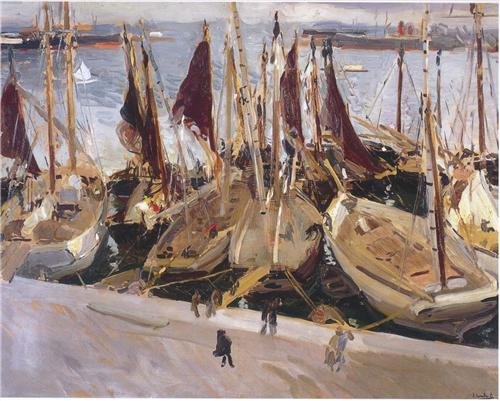What kind of weather seems to be depicted in this scene? The weather depicted in the scene appears to be calm and mild. The water is relatively calm, with gentle ripples that reflect the boats and their sails. The colors in the sky and the absence of dramatic lighting or shadows suggest a clear, perhaps slightly overcast day. This allows the focus to remain on the activity in the harbor rather than any dramatic weather conditions. How does the weather influence the overall atmosphere of the painting? The calm and mild weather contributes to a serene and steady atmosphere, despite the bustling activity in the harbor. The gentle ripples on the water and the soft, muted background create a sense of tranquility that balances the dynamic, lively interaction between the figures and the boats in the foreground. This juxtaposition enhances the overall feeling of a busy yet harmonious scene, where everyday life unfolds against a backdrop of natural beauty and calm. 